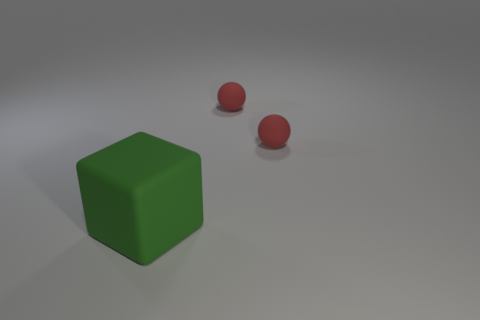What number of other things are there of the same material as the block
Your answer should be very brief. 2. Are there fewer big rubber things that are behind the large matte object than small cyan rubber cubes?
Provide a succinct answer. No. What number of small red balls have the same material as the green object?
Offer a terse response. 2. The green matte thing has what shape?
Keep it short and to the point. Cube. What number of things are things that are on the right side of the cube or red rubber things?
Your answer should be compact. 2. Is there any other thing that is the same size as the green thing?
Provide a succinct answer. No. What number of objects are rubber objects behind the large green rubber object or rubber objects that are on the right side of the green thing?
Offer a very short reply. 2. Is the number of red spheres greater than the number of gray matte spheres?
Your answer should be compact. Yes. Is the number of tiny red matte objects less than the number of tiny metallic cubes?
Provide a short and direct response. No. Are there more small red matte balls right of the big green thing than brown matte balls?
Provide a succinct answer. Yes. 